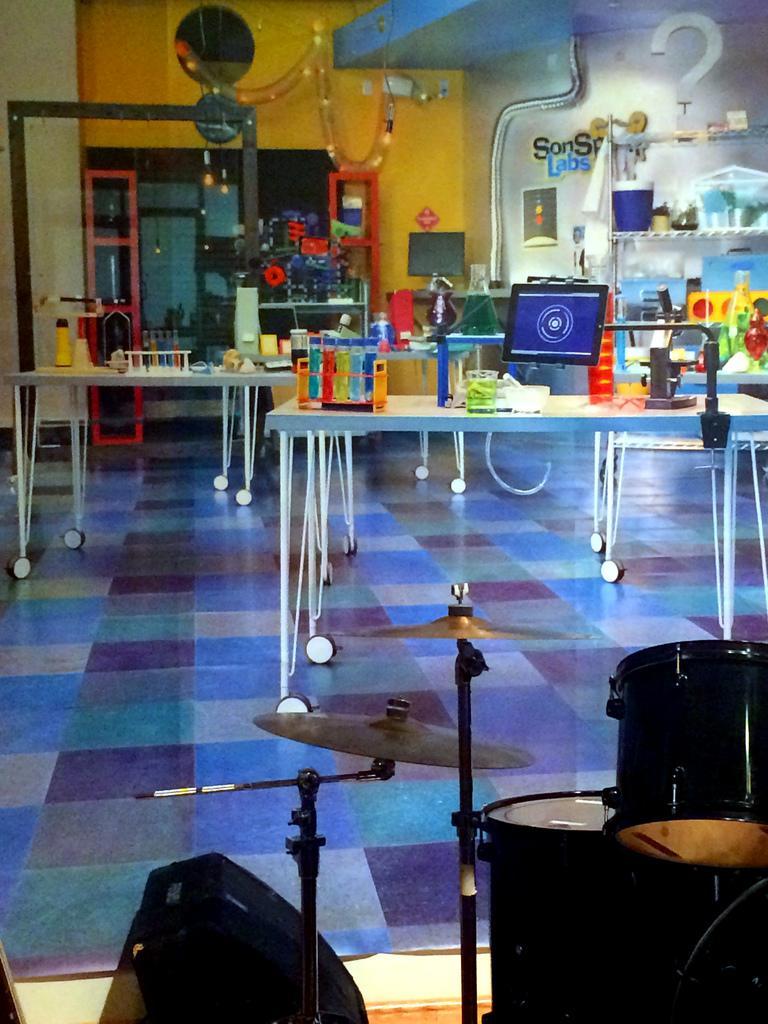Can you describe this image briefly? In this image, there are objects on the tables and in a rack. In the background, I can see a glass door, lights, computer monitor and a poster attached to the wall. At the bottom of the image, there are drums and cymbals with stands. 